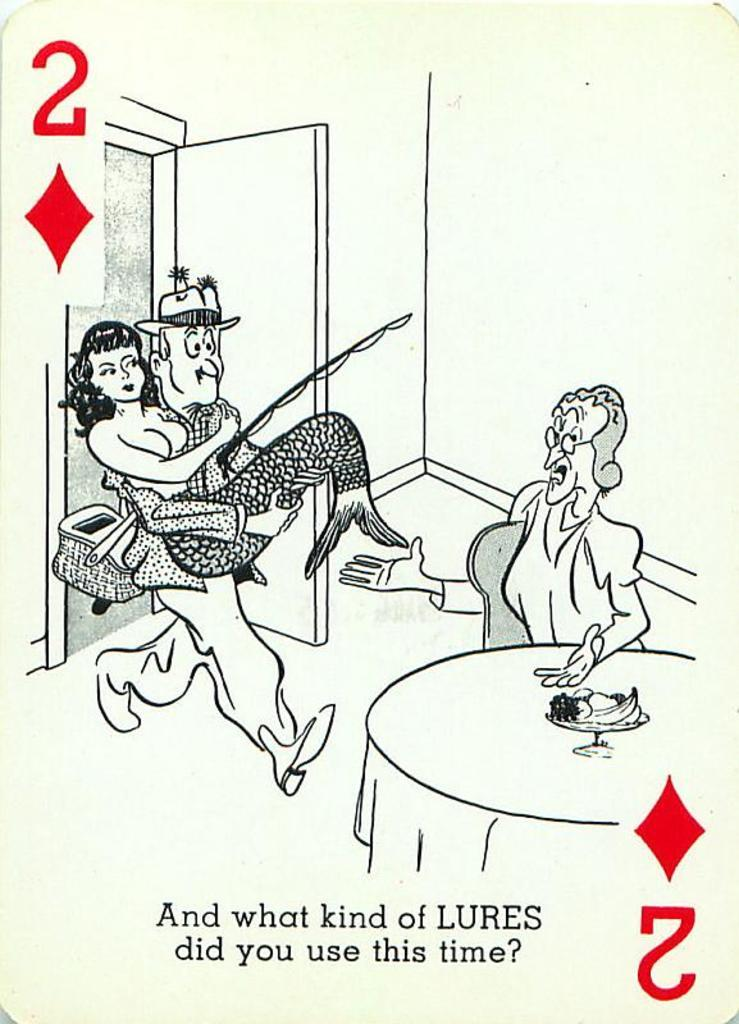What is the main object in the image? There is a card in the image. What can be found on the card? The card has text on it and cartoon images. What is the position of the card in the image? The position of the card in the image cannot be determined from the provided facts. --- 